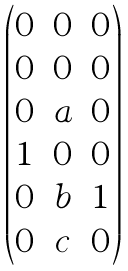<formula> <loc_0><loc_0><loc_500><loc_500>\begin{pmatrix} 0 & 0 & 0 \\ 0 & 0 & 0 \\ 0 & a & 0 \\ 1 & 0 & 0 \\ 0 & b & 1 \\ 0 & c & 0 \end{pmatrix}</formula> 